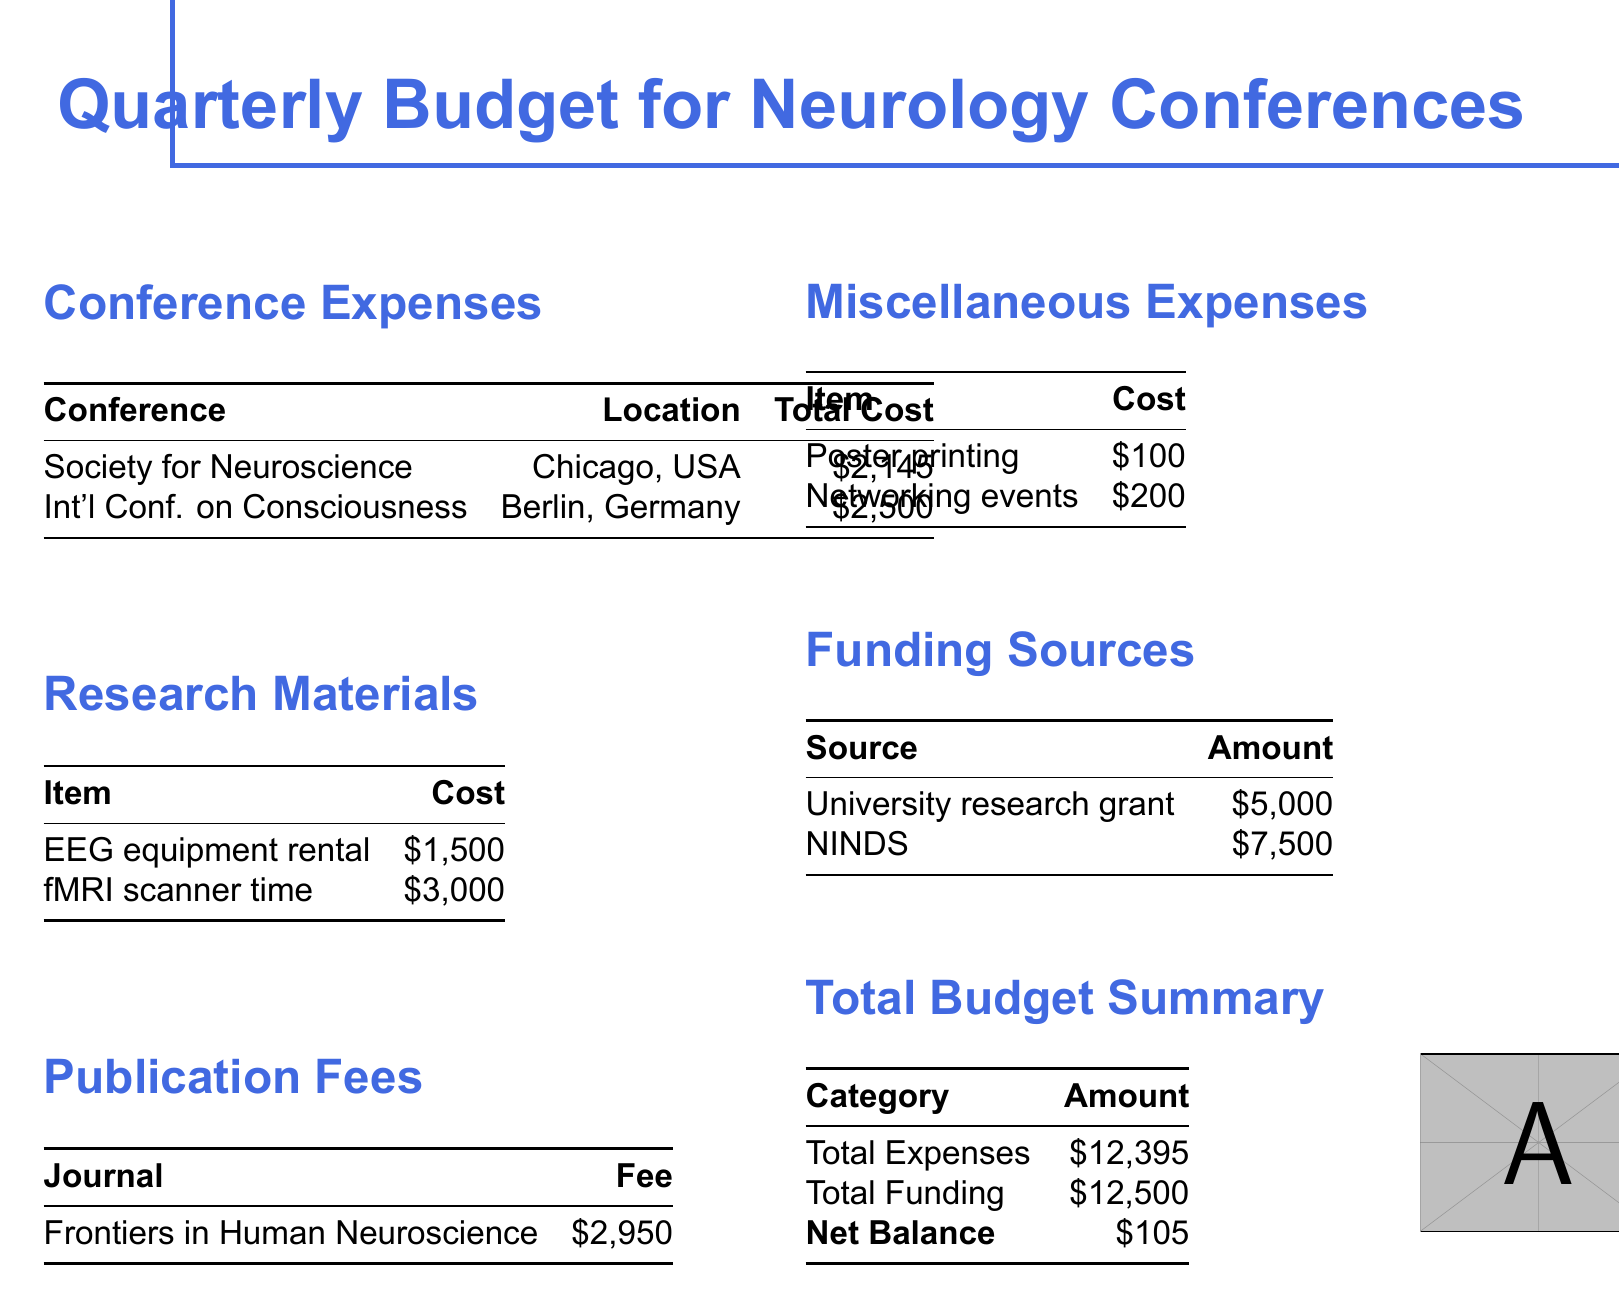what is the total cost for the Society for Neuroscience conference? The total cost is listed in the expenses section of the document under the Society for Neuroscience.
Answer: $2,145 how much does the fMRI scanner time cost? The cost of the fMRI scanner time is found in the research materials section.
Answer: $3,000 what is the fee for the journal Frontiers in Human Neuroscience? The fee for the journal is present in the publication fees section of the document.
Answer: $2,950 what are the total expenses for the conference organizing budget? The total expenses are summarized in the total budget summary section.
Answer: $12,395 how much funding comes from NINDS? The amount from NINDS is specified in the funding sources section.
Answer: $7,500 what is the net balance of the budget? The net balance is calculated by subtracting total expenses from total funding in the total budget summary.
Answer: $105 how many networking events are included in the miscellaneous expenses? The number of networking events specifically is not detailed, but there is a cost listed under miscellaneous expenses.
Answer: 1 what is the total funding amount? The total funding is mentioned in the total budget summary section of the document.
Answer: $12,500 